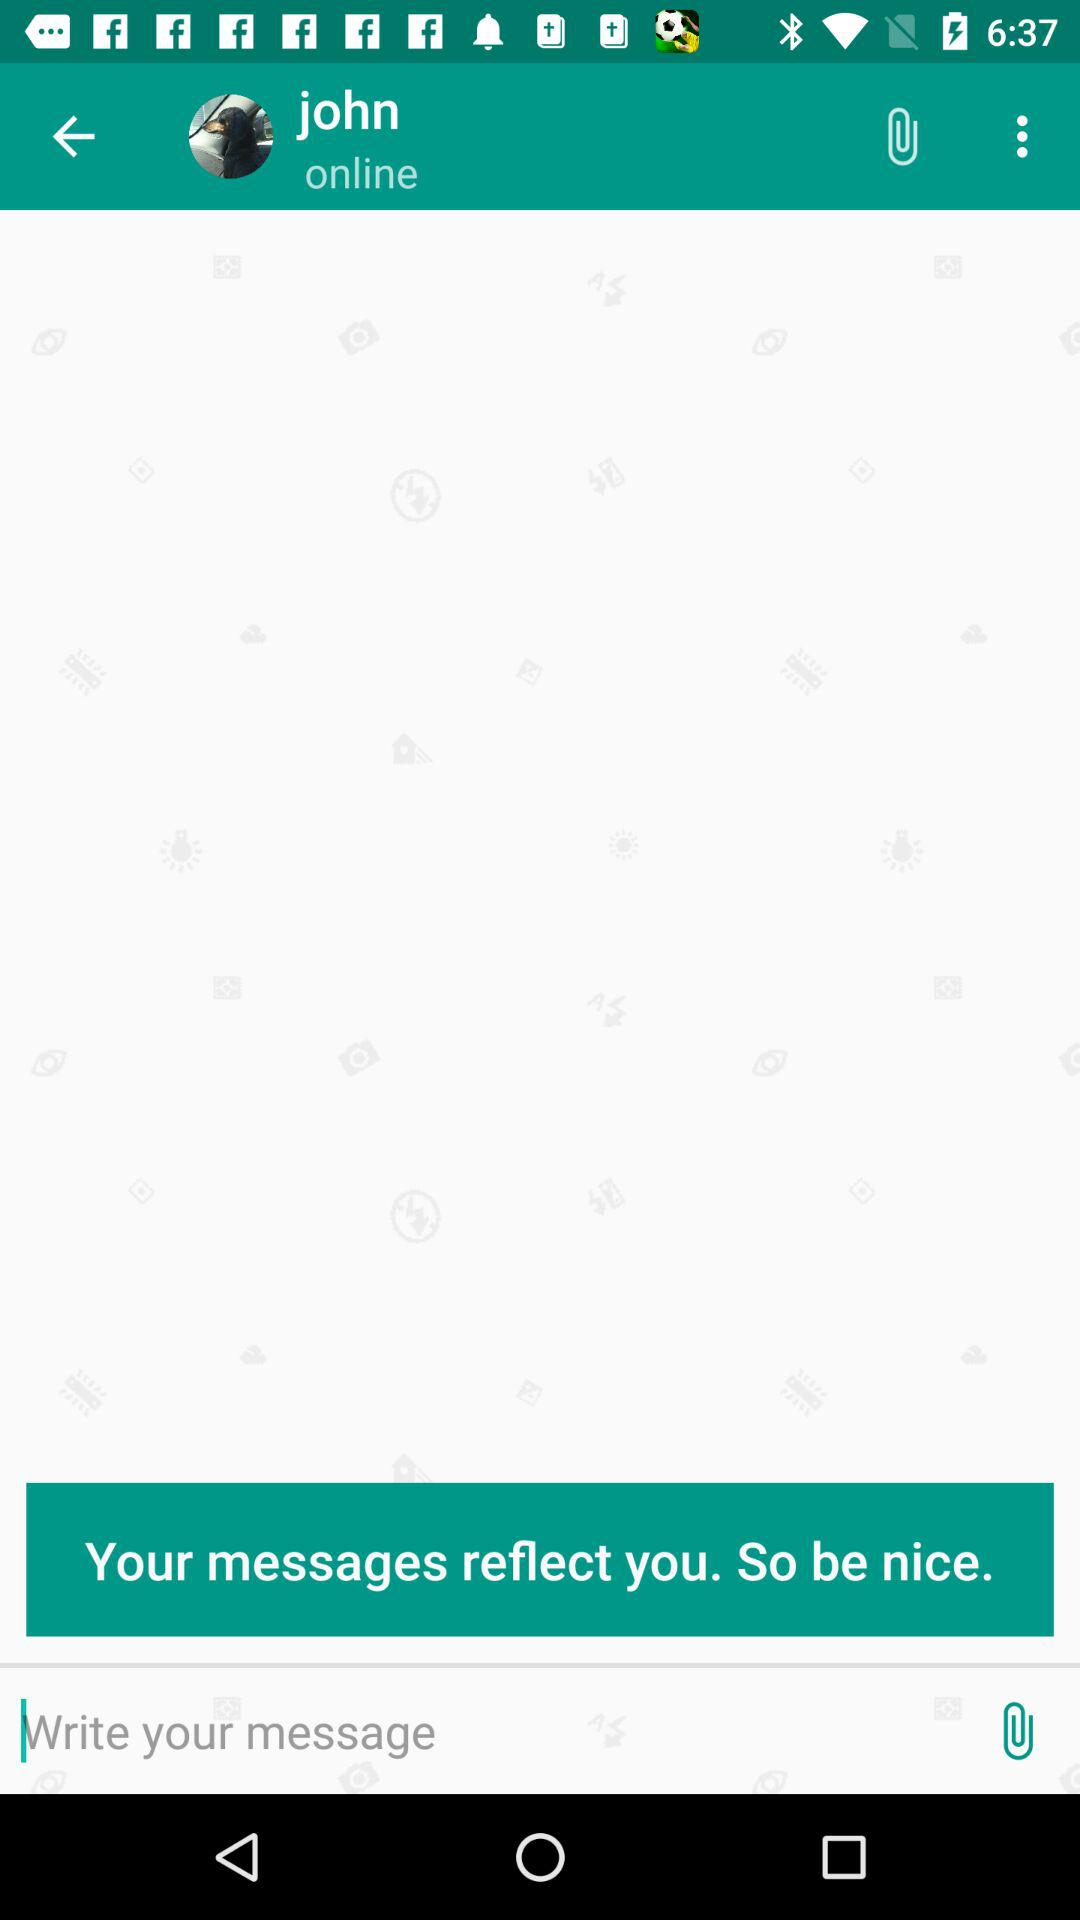What is the name of the user? The name of the user is John. 